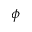<formula> <loc_0><loc_0><loc_500><loc_500>\phi</formula> 